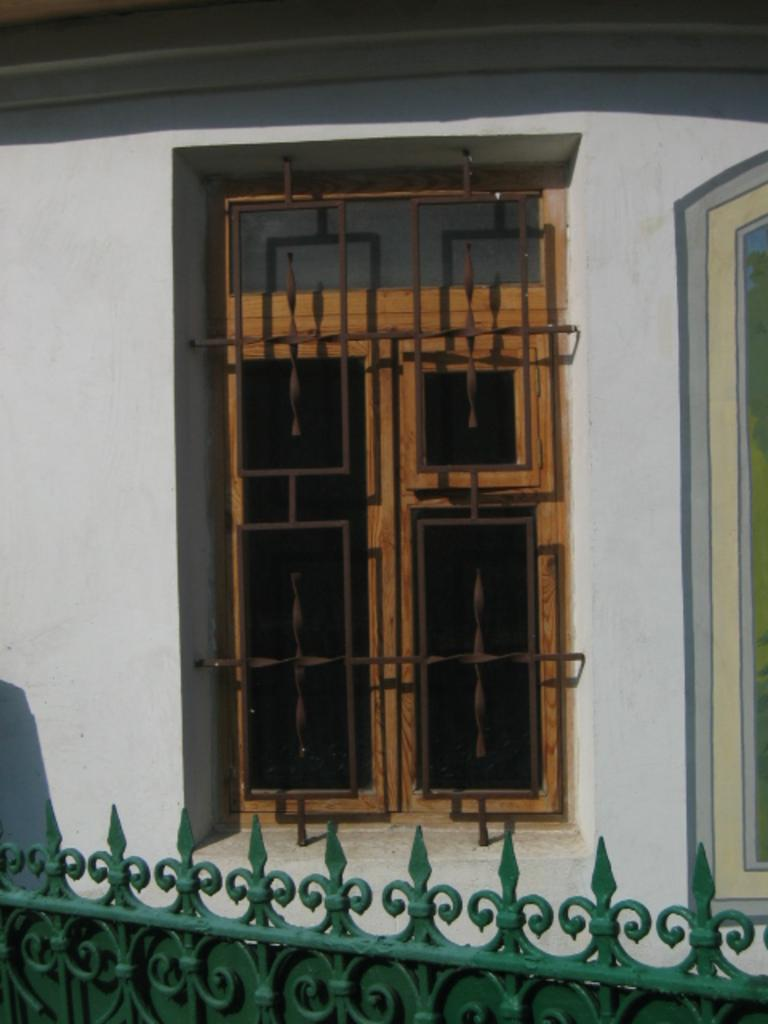What is located in the foreground of the image? There is a green gate in the foreground of the image. What can be seen in the background of the image? There is a closed window and a wall in the background of the image. What type of pie is being baked in the plantation visible in the image? There is no plantation or pie present in the image; it features a green gate in the foreground and a closed window and wall in the background. 